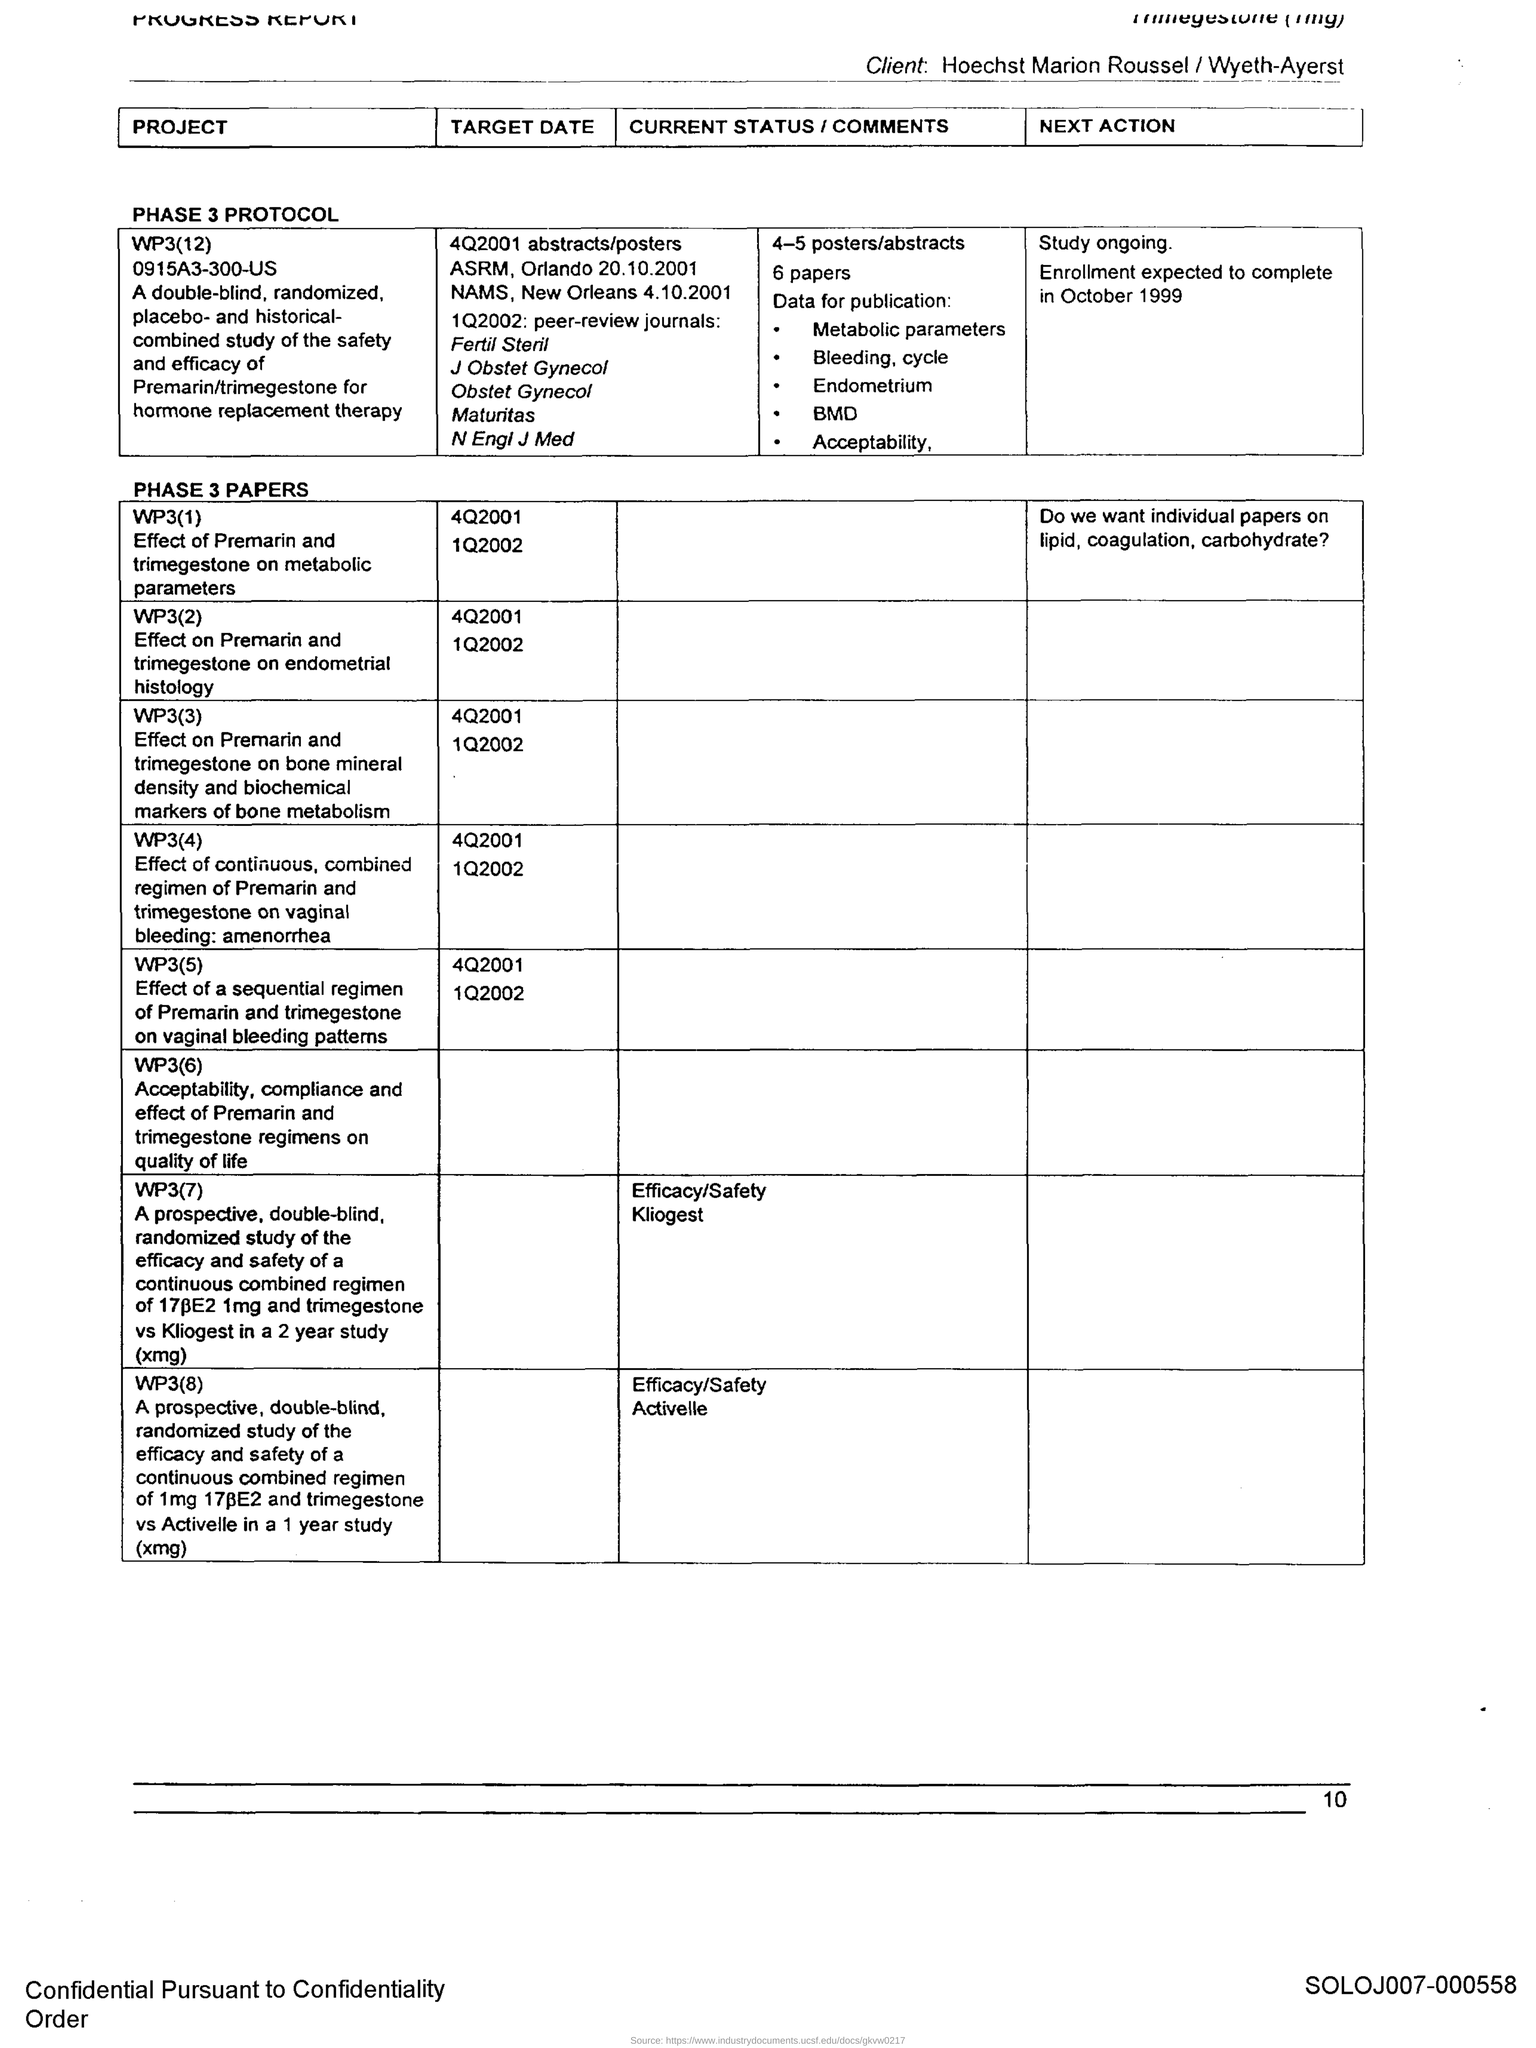What is the Page Number?
Your response must be concise. 10. What is the current status of WP3(8)?
Keep it short and to the point. Efficacy/Safety Activelle. 